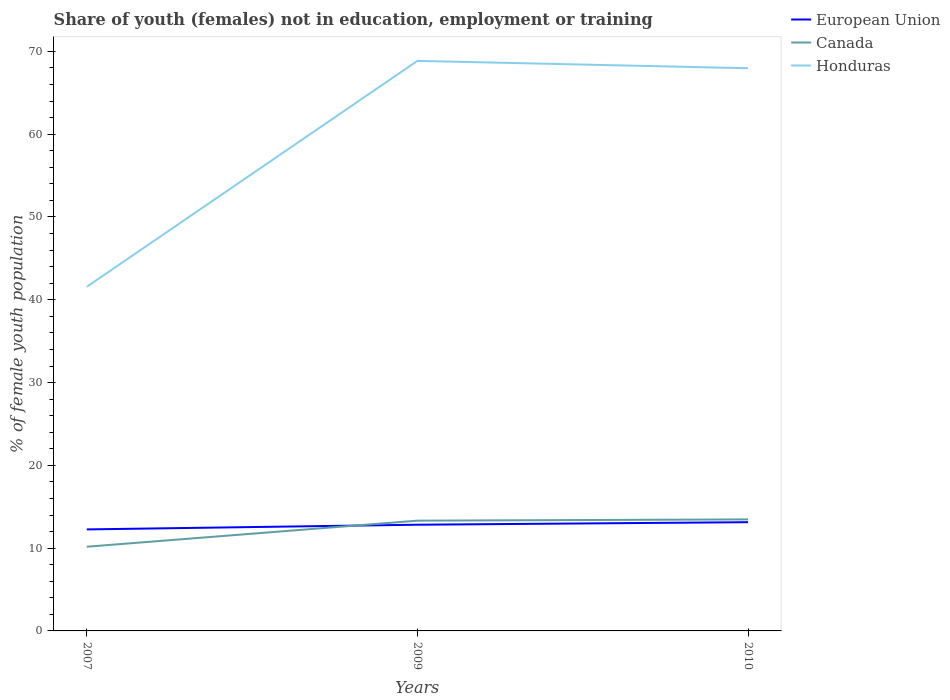How many different coloured lines are there?
Provide a succinct answer. 3. Does the line corresponding to Honduras intersect with the line corresponding to Canada?
Keep it short and to the point. No. Across all years, what is the maximum percentage of unemployed female population in in Honduras?
Ensure brevity in your answer.  41.57. What is the total percentage of unemployed female population in in Canada in the graph?
Your answer should be very brief. -3.15. What is the difference between the highest and the second highest percentage of unemployed female population in in Honduras?
Make the answer very short. 27.29. What is the difference between the highest and the lowest percentage of unemployed female population in in Honduras?
Make the answer very short. 2. How many years are there in the graph?
Offer a terse response. 3. How many legend labels are there?
Give a very brief answer. 3. What is the title of the graph?
Your answer should be compact. Share of youth (females) not in education, employment or training. What is the label or title of the Y-axis?
Your response must be concise. % of female youth population. What is the % of female youth population in European Union in 2007?
Provide a short and direct response. 12.26. What is the % of female youth population in Canada in 2007?
Offer a very short reply. 10.17. What is the % of female youth population of Honduras in 2007?
Give a very brief answer. 41.57. What is the % of female youth population of European Union in 2009?
Your response must be concise. 12.83. What is the % of female youth population in Canada in 2009?
Give a very brief answer. 13.32. What is the % of female youth population of Honduras in 2009?
Your response must be concise. 68.86. What is the % of female youth population in European Union in 2010?
Provide a short and direct response. 13.13. What is the % of female youth population of Canada in 2010?
Your answer should be very brief. 13.47. What is the % of female youth population in Honduras in 2010?
Give a very brief answer. 67.97. Across all years, what is the maximum % of female youth population in European Union?
Keep it short and to the point. 13.13. Across all years, what is the maximum % of female youth population of Canada?
Your answer should be very brief. 13.47. Across all years, what is the maximum % of female youth population in Honduras?
Your response must be concise. 68.86. Across all years, what is the minimum % of female youth population in European Union?
Provide a succinct answer. 12.26. Across all years, what is the minimum % of female youth population of Canada?
Give a very brief answer. 10.17. Across all years, what is the minimum % of female youth population of Honduras?
Your answer should be compact. 41.57. What is the total % of female youth population of European Union in the graph?
Your answer should be compact. 38.23. What is the total % of female youth population in Canada in the graph?
Offer a terse response. 36.96. What is the total % of female youth population in Honduras in the graph?
Provide a short and direct response. 178.4. What is the difference between the % of female youth population in European Union in 2007 and that in 2009?
Keep it short and to the point. -0.57. What is the difference between the % of female youth population in Canada in 2007 and that in 2009?
Make the answer very short. -3.15. What is the difference between the % of female youth population in Honduras in 2007 and that in 2009?
Provide a succinct answer. -27.29. What is the difference between the % of female youth population in European Union in 2007 and that in 2010?
Ensure brevity in your answer.  -0.87. What is the difference between the % of female youth population of Honduras in 2007 and that in 2010?
Your response must be concise. -26.4. What is the difference between the % of female youth population in European Union in 2009 and that in 2010?
Provide a succinct answer. -0.3. What is the difference between the % of female youth population in Canada in 2009 and that in 2010?
Your answer should be very brief. -0.15. What is the difference between the % of female youth population in Honduras in 2009 and that in 2010?
Keep it short and to the point. 0.89. What is the difference between the % of female youth population of European Union in 2007 and the % of female youth population of Canada in 2009?
Ensure brevity in your answer.  -1.06. What is the difference between the % of female youth population of European Union in 2007 and the % of female youth population of Honduras in 2009?
Keep it short and to the point. -56.6. What is the difference between the % of female youth population of Canada in 2007 and the % of female youth population of Honduras in 2009?
Keep it short and to the point. -58.69. What is the difference between the % of female youth population of European Union in 2007 and the % of female youth population of Canada in 2010?
Your response must be concise. -1.21. What is the difference between the % of female youth population of European Union in 2007 and the % of female youth population of Honduras in 2010?
Give a very brief answer. -55.71. What is the difference between the % of female youth population of Canada in 2007 and the % of female youth population of Honduras in 2010?
Offer a very short reply. -57.8. What is the difference between the % of female youth population of European Union in 2009 and the % of female youth population of Canada in 2010?
Your response must be concise. -0.64. What is the difference between the % of female youth population in European Union in 2009 and the % of female youth population in Honduras in 2010?
Provide a succinct answer. -55.14. What is the difference between the % of female youth population of Canada in 2009 and the % of female youth population of Honduras in 2010?
Your response must be concise. -54.65. What is the average % of female youth population of European Union per year?
Your response must be concise. 12.74. What is the average % of female youth population in Canada per year?
Give a very brief answer. 12.32. What is the average % of female youth population in Honduras per year?
Your response must be concise. 59.47. In the year 2007, what is the difference between the % of female youth population of European Union and % of female youth population of Canada?
Your answer should be compact. 2.09. In the year 2007, what is the difference between the % of female youth population of European Union and % of female youth population of Honduras?
Your answer should be compact. -29.31. In the year 2007, what is the difference between the % of female youth population of Canada and % of female youth population of Honduras?
Provide a short and direct response. -31.4. In the year 2009, what is the difference between the % of female youth population in European Union and % of female youth population in Canada?
Provide a short and direct response. -0.49. In the year 2009, what is the difference between the % of female youth population of European Union and % of female youth population of Honduras?
Provide a succinct answer. -56.03. In the year 2009, what is the difference between the % of female youth population in Canada and % of female youth population in Honduras?
Make the answer very short. -55.54. In the year 2010, what is the difference between the % of female youth population in European Union and % of female youth population in Canada?
Keep it short and to the point. -0.34. In the year 2010, what is the difference between the % of female youth population of European Union and % of female youth population of Honduras?
Ensure brevity in your answer.  -54.84. In the year 2010, what is the difference between the % of female youth population in Canada and % of female youth population in Honduras?
Offer a terse response. -54.5. What is the ratio of the % of female youth population in European Union in 2007 to that in 2009?
Offer a very short reply. 0.96. What is the ratio of the % of female youth population of Canada in 2007 to that in 2009?
Keep it short and to the point. 0.76. What is the ratio of the % of female youth population of Honduras in 2007 to that in 2009?
Your answer should be very brief. 0.6. What is the ratio of the % of female youth population in European Union in 2007 to that in 2010?
Give a very brief answer. 0.93. What is the ratio of the % of female youth population in Canada in 2007 to that in 2010?
Provide a succinct answer. 0.76. What is the ratio of the % of female youth population in Honduras in 2007 to that in 2010?
Keep it short and to the point. 0.61. What is the ratio of the % of female youth population in European Union in 2009 to that in 2010?
Give a very brief answer. 0.98. What is the ratio of the % of female youth population of Canada in 2009 to that in 2010?
Offer a terse response. 0.99. What is the ratio of the % of female youth population in Honduras in 2009 to that in 2010?
Your response must be concise. 1.01. What is the difference between the highest and the second highest % of female youth population of European Union?
Your answer should be very brief. 0.3. What is the difference between the highest and the second highest % of female youth population of Canada?
Provide a short and direct response. 0.15. What is the difference between the highest and the second highest % of female youth population of Honduras?
Your answer should be compact. 0.89. What is the difference between the highest and the lowest % of female youth population of European Union?
Offer a very short reply. 0.87. What is the difference between the highest and the lowest % of female youth population in Canada?
Your response must be concise. 3.3. What is the difference between the highest and the lowest % of female youth population of Honduras?
Provide a short and direct response. 27.29. 